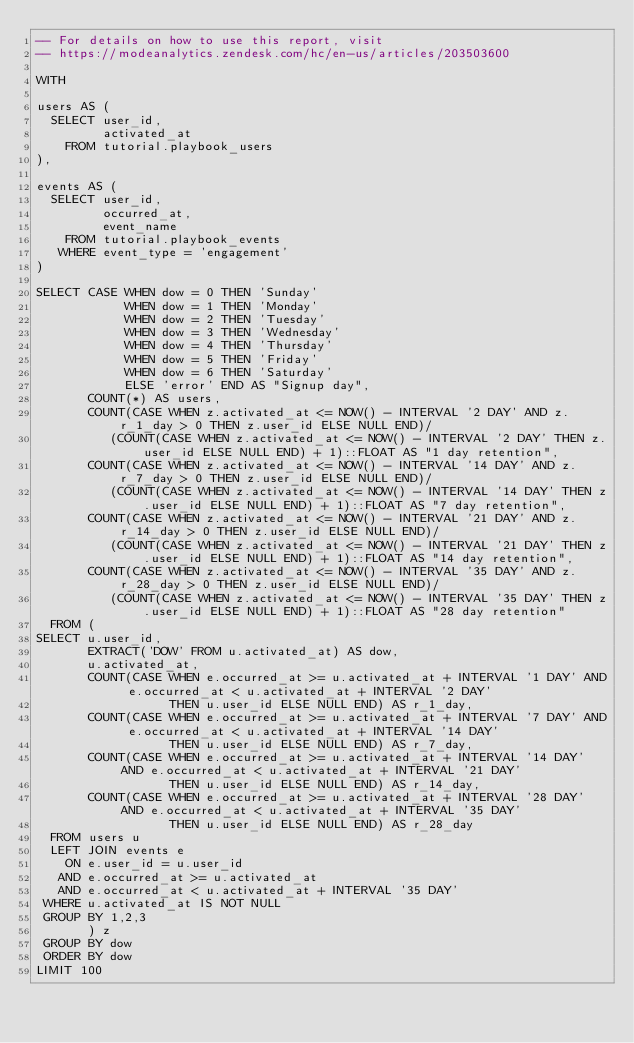<code> <loc_0><loc_0><loc_500><loc_500><_SQL_>-- For details on how to use this report, visit
-- https://modeanalytics.zendesk.com/hc/en-us/articles/203503600

WITH 

users AS (
  SELECT user_id,
         activated_at
    FROM tutorial.playbook_users
),

events AS (
  SELECT user_id,
         occurred_at,
         event_name
    FROM tutorial.playbook_events
   WHERE event_type = 'engagement'
)

SELECT CASE WHEN dow = 0 THEN 'Sunday'
            WHEN dow = 1 THEN 'Monday'
            WHEN dow = 2 THEN 'Tuesday'
            WHEN dow = 3 THEN 'Wednesday'
            WHEN dow = 4 THEN 'Thursday'
            WHEN dow = 5 THEN 'Friday'
            WHEN dow = 6 THEN 'Saturday'
            ELSE 'error' END AS "Signup day",
       COUNT(*) AS users,
       COUNT(CASE WHEN z.activated_at <= NOW() - INTERVAL '2 DAY' AND z.r_1_day > 0 THEN z.user_id ELSE NULL END)/
          (COUNT(CASE WHEN z.activated_at <= NOW() - INTERVAL '2 DAY' THEN z.user_id ELSE NULL END) + 1)::FLOAT AS "1 day retention",
       COUNT(CASE WHEN z.activated_at <= NOW() - INTERVAL '14 DAY' AND z.r_7_day > 0 THEN z.user_id ELSE NULL END)/
          (COUNT(CASE WHEN z.activated_at <= NOW() - INTERVAL '14 DAY' THEN z.user_id ELSE NULL END) + 1)::FLOAT AS "7 day retention",
       COUNT(CASE WHEN z.activated_at <= NOW() - INTERVAL '21 DAY' AND z.r_14_day > 0 THEN z.user_id ELSE NULL END)/
          (COUNT(CASE WHEN z.activated_at <= NOW() - INTERVAL '21 DAY' THEN z.user_id ELSE NULL END) + 1)::FLOAT AS "14 day retention",
       COUNT(CASE WHEN z.activated_at <= NOW() - INTERVAL '35 DAY' AND z.r_28_day > 0 THEN z.user_id ELSE NULL END)/
          (COUNT(CASE WHEN z.activated_at <= NOW() - INTERVAL '35 DAY' THEN z.user_id ELSE NULL END) + 1)::FLOAT AS "28 day retention"
  FROM (
SELECT u.user_id,
       EXTRACT('DOW' FROM u.activated_at) AS dow,
       u.activated_at,
       COUNT(CASE WHEN e.occurred_at >= u.activated_at + INTERVAL '1 DAY' AND e.occurred_at < u.activated_at + INTERVAL '2 DAY' 
                  THEN u.user_id ELSE NULL END) AS r_1_day,
       COUNT(CASE WHEN e.occurred_at >= u.activated_at + INTERVAL '7 DAY' AND e.occurred_at < u.activated_at + INTERVAL '14 DAY' 
                  THEN u.user_id ELSE NULL END) AS r_7_day,
       COUNT(CASE WHEN e.occurred_at >= u.activated_at + INTERVAL '14 DAY' AND e.occurred_at < u.activated_at + INTERVAL '21 DAY' 
                  THEN u.user_id ELSE NULL END) AS r_14_day,
       COUNT(CASE WHEN e.occurred_at >= u.activated_at + INTERVAL '28 DAY' AND e.occurred_at < u.activated_at + INTERVAL '35 DAY' 
                  THEN u.user_id ELSE NULL END) AS r_28_day
  FROM users u
  LEFT JOIN events e
    ON e.user_id = u.user_id
   AND e.occurred_at >= u.activated_at
   AND e.occurred_at < u.activated_at + INTERVAL '35 DAY'
 WHERE u.activated_at IS NOT NULL
 GROUP BY 1,2,3
       ) z
 GROUP BY dow
 ORDER BY dow
LIMIT 100</code> 